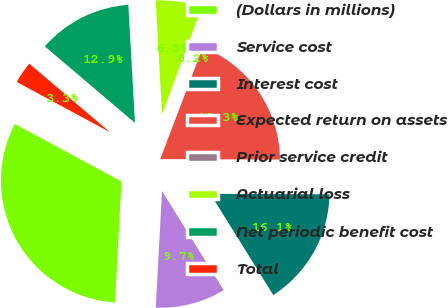Convert chart to OTSL. <chart><loc_0><loc_0><loc_500><loc_500><pie_chart><fcel>(Dollars in millions)<fcel>Service cost<fcel>Interest cost<fcel>Expected return on assets<fcel>Prior service credit<fcel>Actuarial loss<fcel>Net periodic benefit cost<fcel>Total<nl><fcel>32.01%<fcel>9.71%<fcel>16.08%<fcel>19.27%<fcel>0.16%<fcel>6.53%<fcel>12.9%<fcel>3.34%<nl></chart> 